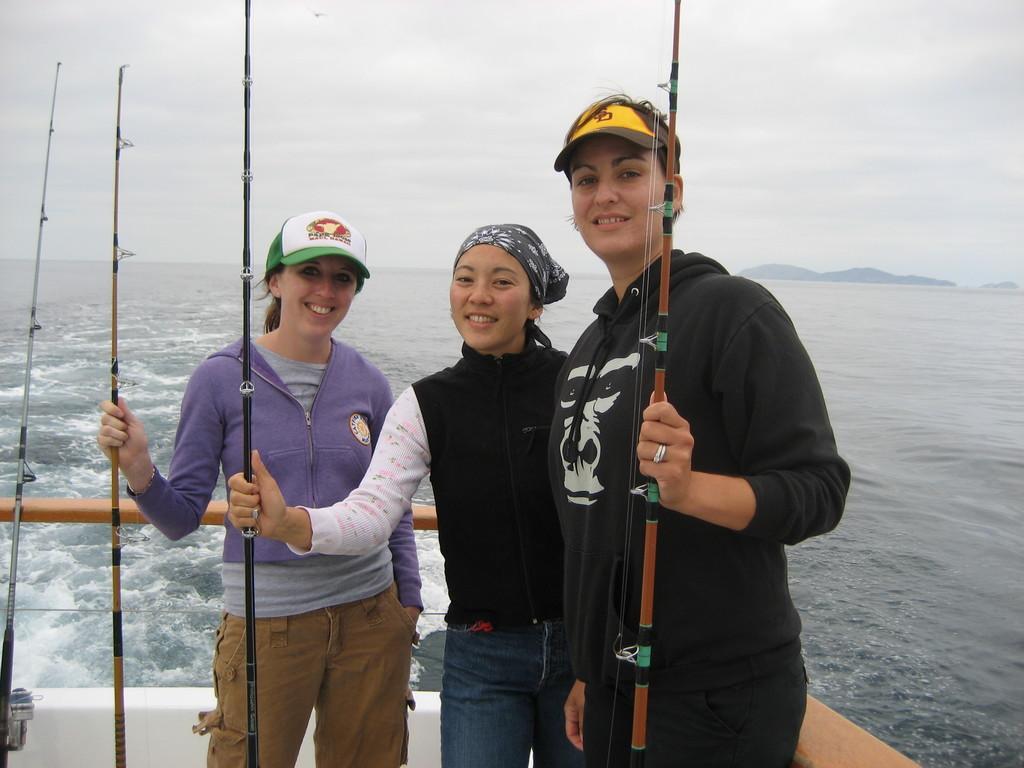Describe this image in one or two sentences. In this picture we can see three women are standing and smiling, they are holding fishing rods, in the background there is water, we can see the sky at the top of the picture. 